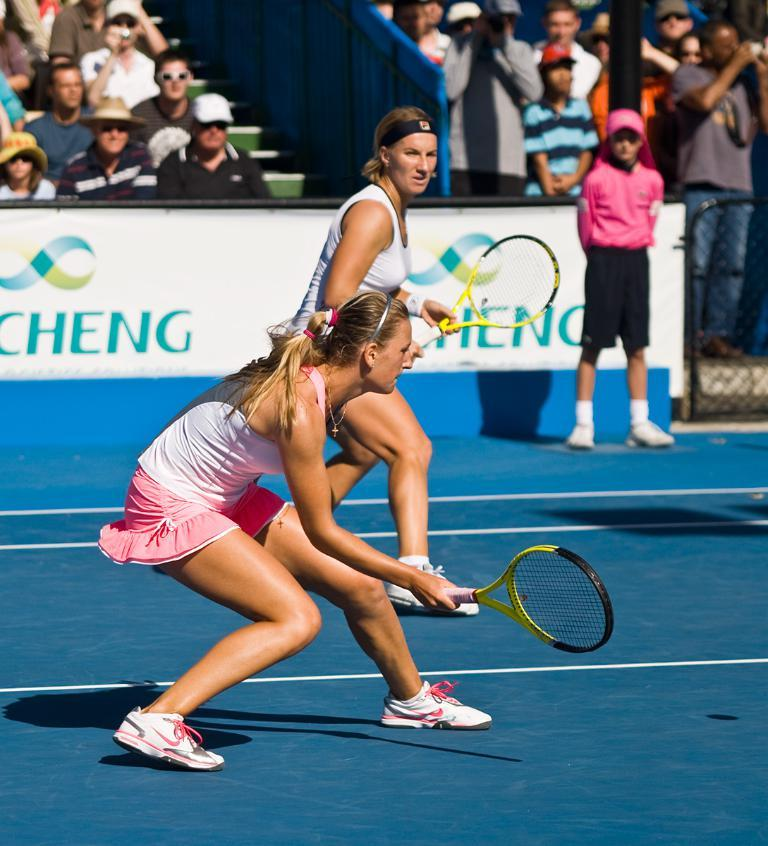Who is the main subject in the image? There is a woman in the image. What is the woman doing in the image? The woman is standing and playing in the image. What is the woman holding in her hands? The woman is holding a racket in her hands. Can you describe the people in the background of the image? There is a group of persons in the background of the image, some of whom are sitting and some of whom are standing. What type of ice can be seen melting on the yard in the image? There is no ice or yard present in the image; it features a woman playing with a racket and a group of persons in the background. 